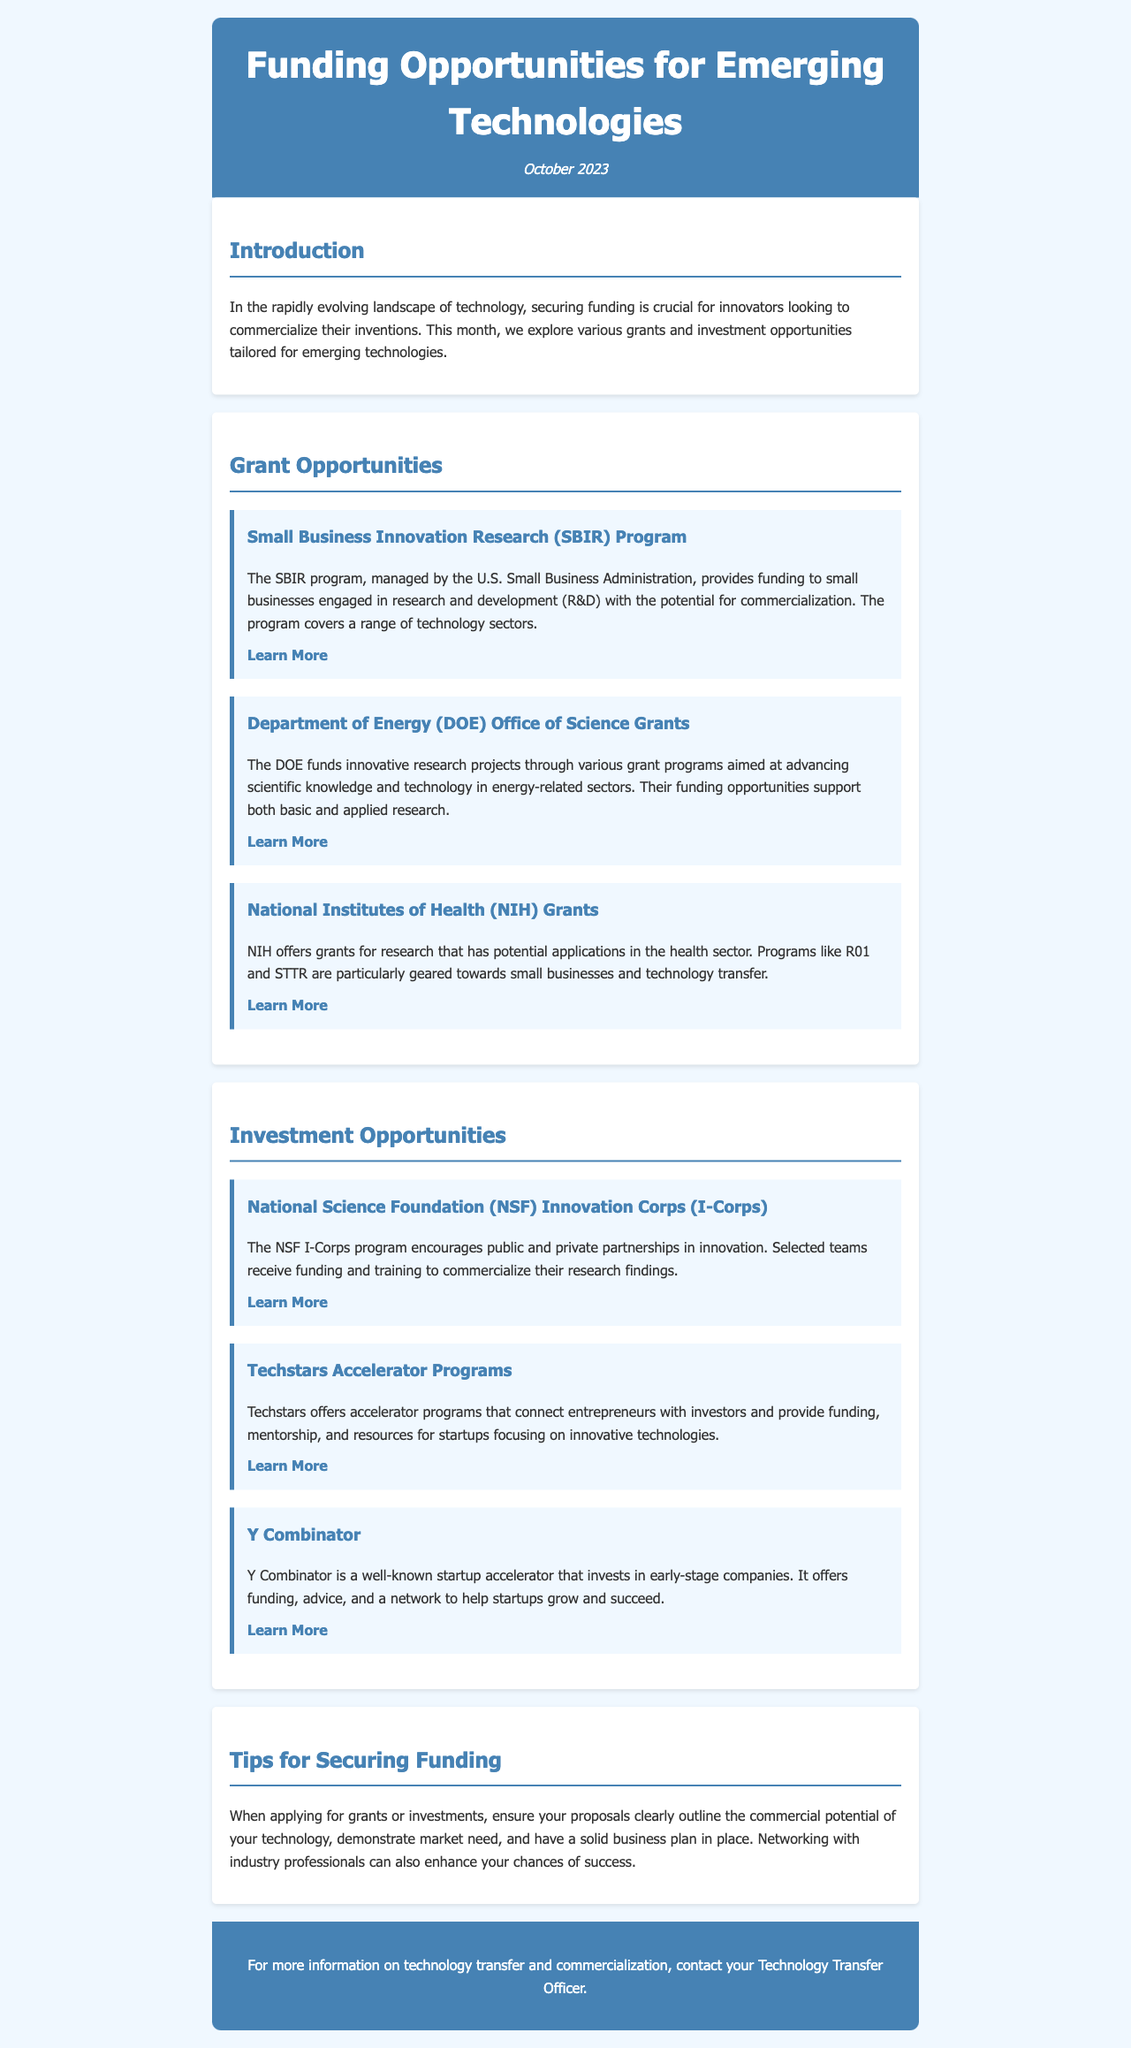What is the title of the newsletter? The title of the newsletter is specified in the header section of the document, which is "Funding Opportunities for Emerging Technologies."
Answer: Funding Opportunities for Emerging Technologies When was the newsletter published? The publication date is provided under the title in the header section, which is "October 2023."
Answer: October 2023 What funding opportunity is managed by the U.S. Small Business Administration? The specific funding opportunity managed by the U.S. Small Business Administration is mentioned under Grant Opportunities as the "SBIR Program."
Answer: SBIR Program What are the two programs offered by the National Institutes of Health? The document describes two specific programs under NIH grants which are "R01" and "STTR."
Answer: R01 and STTR Which program encourages public and private partnerships in innovation? The program that encourages such partnerships is identified as the "NSF Innovation Corps (I-Corps)."
Answer: NSF Innovation Corps (I-Corps) What is one key tip for securing funding mentioned in the newsletter? A key tip included in the document stresses the importance of outlining the "commercial potential of your technology."
Answer: commercial potential of your technology How many investment opportunities are listed in the newsletter? The investment opportunities section lists three specific programs.
Answer: 3 What type of organizations does Techstars connect entrepreneurs with? Techstars connects entrepreneurs with "investors."
Answer: investors What is the main focus of the grants provided by the Department of Energy? The main focus of the DOE grants is to advance "scientific knowledge and technology in energy-related sectors."
Answer: scientific knowledge and technology in energy-related sectors 